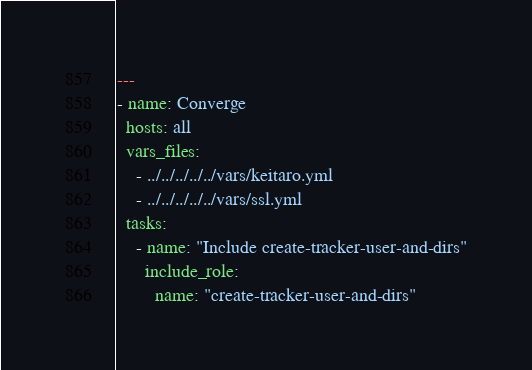<code> <loc_0><loc_0><loc_500><loc_500><_YAML_>---
- name: Converge
  hosts: all
  vars_files:
    - ../../../../../vars/keitaro.yml
    - ../../../../../vars/ssl.yml
  tasks:
    - name: "Include create-tracker-user-and-dirs"
      include_role:
        name: "create-tracker-user-and-dirs"
</code> 